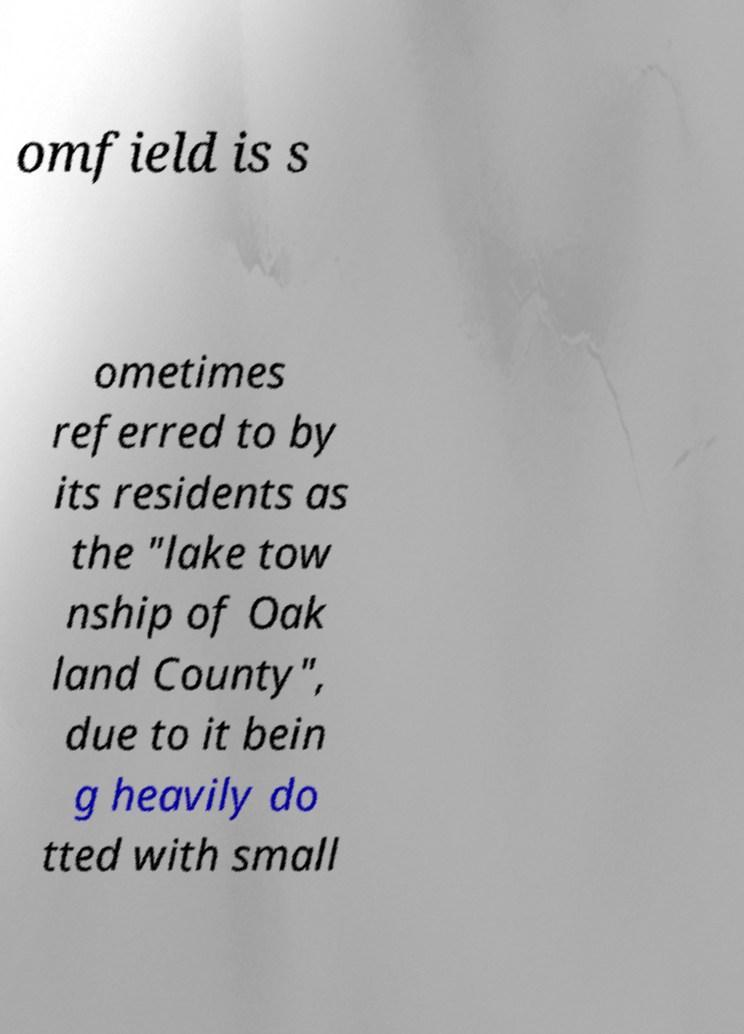For documentation purposes, I need the text within this image transcribed. Could you provide that? omfield is s ometimes referred to by its residents as the "lake tow nship of Oak land County", due to it bein g heavily do tted with small 